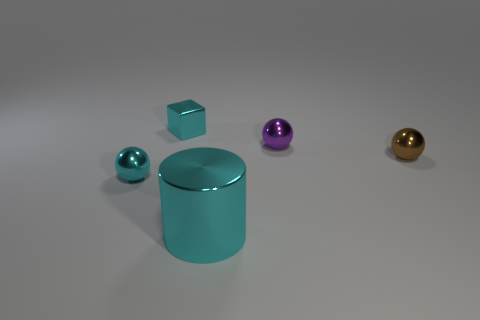How many other objects are there of the same material as the cyan cube?
Provide a succinct answer. 4. What number of objects are tiny objects that are on the right side of the metal block or shiny cylinders?
Ensure brevity in your answer.  3. There is a thing that is in front of the tiny metal sphere to the left of the large cyan cylinder; what shape is it?
Your answer should be very brief. Cylinder. Do the small thing that is in front of the brown object and the tiny purple metallic object have the same shape?
Offer a terse response. Yes. What color is the big metallic thing that is in front of the cyan cube?
Provide a short and direct response. Cyan. How many spheres are either purple metallic things or cyan things?
Offer a terse response. 2. There is a shiny ball on the left side of the thing that is in front of the small cyan sphere; what is its size?
Offer a very short reply. Small. Does the big metallic cylinder have the same color as the small shiny sphere that is behind the brown object?
Your answer should be very brief. No. How many shiny balls are in front of the purple sphere?
Provide a succinct answer. 2. Are there fewer large green rubber cylinders than purple metal things?
Offer a terse response. Yes. 